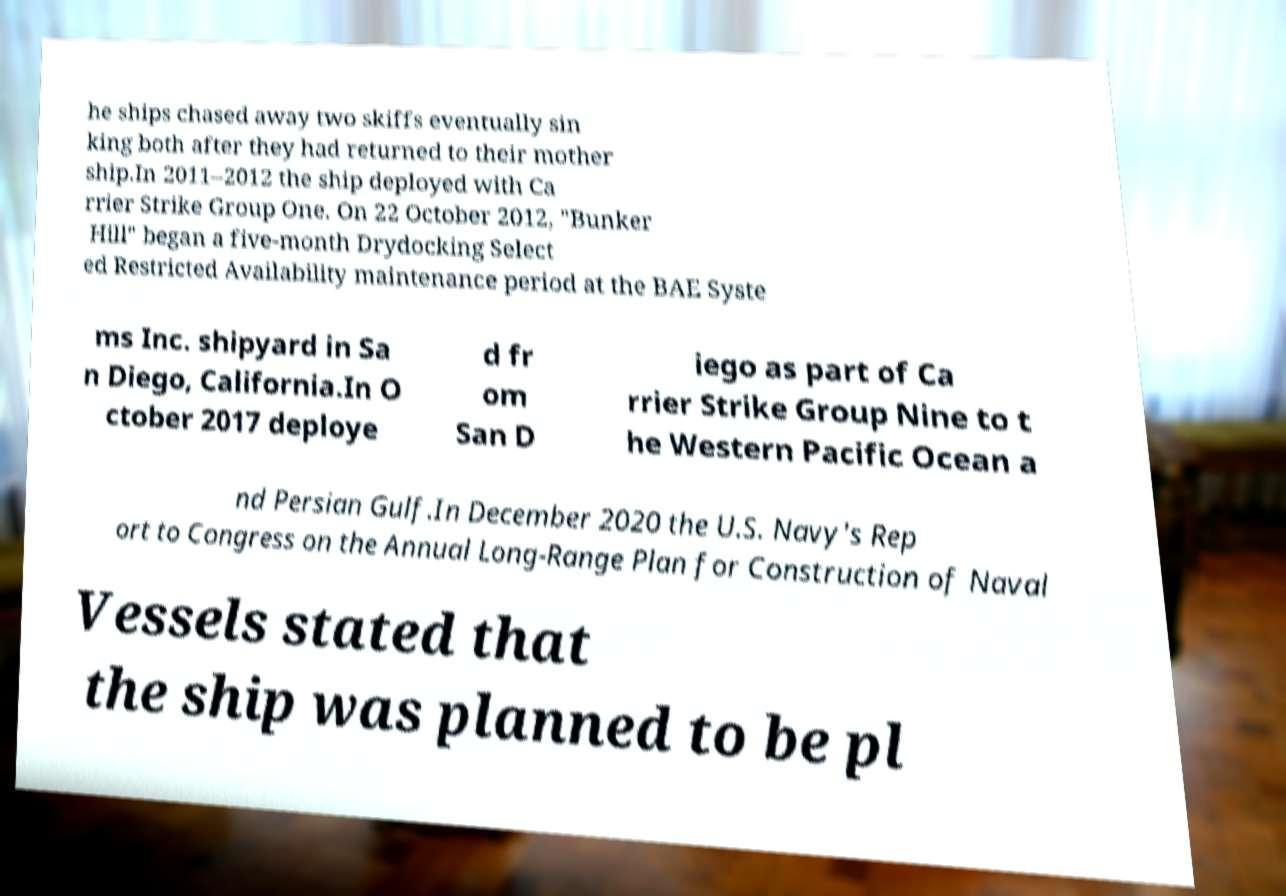Can you read and provide the text displayed in the image?This photo seems to have some interesting text. Can you extract and type it out for me? he ships chased away two skiffs eventually sin king both after they had returned to their mother ship.In 2011–2012 the ship deployed with Ca rrier Strike Group One. On 22 October 2012, "Bunker Hill" began a five-month Drydocking Select ed Restricted Availability maintenance period at the BAE Syste ms Inc. shipyard in Sa n Diego, California.In O ctober 2017 deploye d fr om San D iego as part of Ca rrier Strike Group Nine to t he Western Pacific Ocean a nd Persian Gulf.In December 2020 the U.S. Navy's Rep ort to Congress on the Annual Long-Range Plan for Construction of Naval Vessels stated that the ship was planned to be pl 